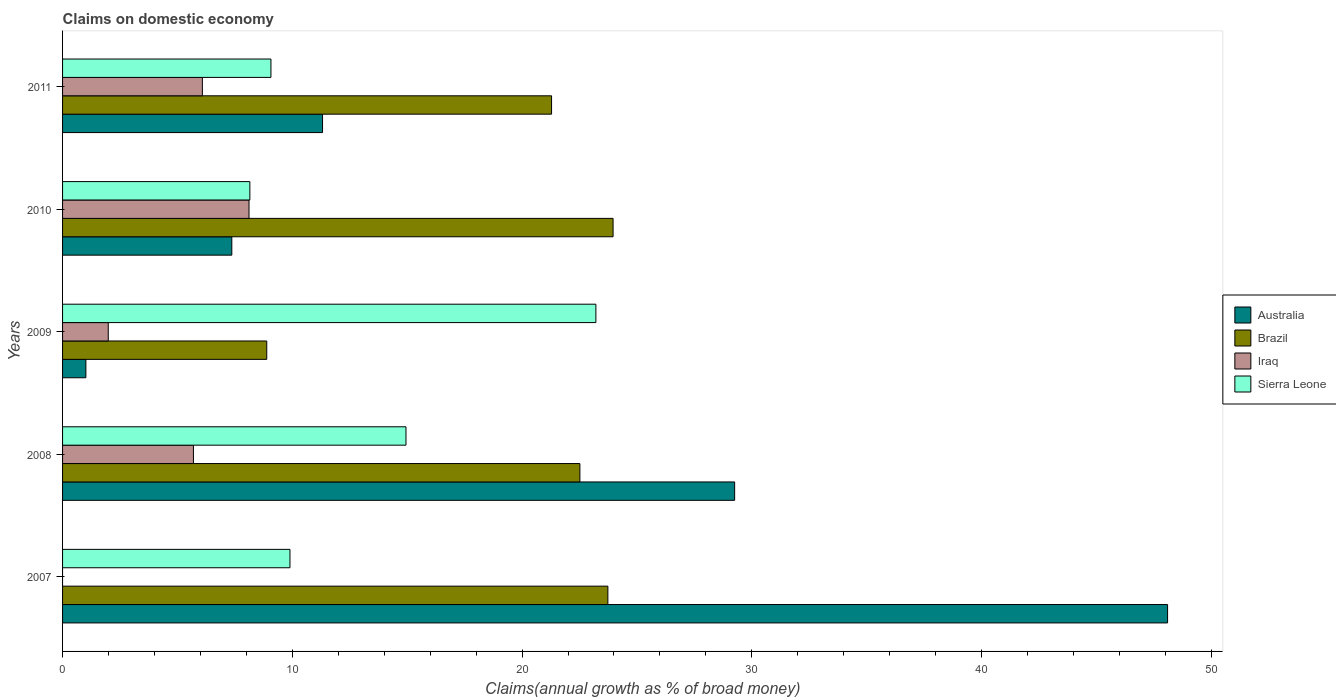How many groups of bars are there?
Provide a succinct answer. 5. Are the number of bars per tick equal to the number of legend labels?
Your response must be concise. No. How many bars are there on the 5th tick from the top?
Your answer should be compact. 3. How many bars are there on the 2nd tick from the bottom?
Keep it short and to the point. 4. What is the label of the 3rd group of bars from the top?
Your answer should be compact. 2009. What is the percentage of broad money claimed on domestic economy in Brazil in 2010?
Your answer should be compact. 23.96. Across all years, what is the maximum percentage of broad money claimed on domestic economy in Australia?
Your response must be concise. 48.1. Across all years, what is the minimum percentage of broad money claimed on domestic economy in Iraq?
Your answer should be very brief. 0. What is the total percentage of broad money claimed on domestic economy in Australia in the graph?
Your response must be concise. 97.05. What is the difference between the percentage of broad money claimed on domestic economy in Brazil in 2009 and that in 2010?
Provide a succinct answer. -15.07. What is the difference between the percentage of broad money claimed on domestic economy in Iraq in 2009 and the percentage of broad money claimed on domestic economy in Brazil in 2011?
Provide a short and direct response. -19.3. What is the average percentage of broad money claimed on domestic economy in Sierra Leone per year?
Your response must be concise. 13.06. In the year 2008, what is the difference between the percentage of broad money claimed on domestic economy in Brazil and percentage of broad money claimed on domestic economy in Australia?
Offer a terse response. -6.74. In how many years, is the percentage of broad money claimed on domestic economy in Iraq greater than 40 %?
Offer a very short reply. 0. What is the ratio of the percentage of broad money claimed on domestic economy in Iraq in 2010 to that in 2011?
Keep it short and to the point. 1.33. Is the percentage of broad money claimed on domestic economy in Brazil in 2007 less than that in 2011?
Your answer should be very brief. No. Is the difference between the percentage of broad money claimed on domestic economy in Brazil in 2007 and 2011 greater than the difference between the percentage of broad money claimed on domestic economy in Australia in 2007 and 2011?
Provide a short and direct response. No. What is the difference between the highest and the second highest percentage of broad money claimed on domestic economy in Australia?
Your answer should be very brief. 18.84. What is the difference between the highest and the lowest percentage of broad money claimed on domestic economy in Brazil?
Make the answer very short. 15.07. Is it the case that in every year, the sum of the percentage of broad money claimed on domestic economy in Sierra Leone and percentage of broad money claimed on domestic economy in Brazil is greater than the sum of percentage of broad money claimed on domestic economy in Australia and percentage of broad money claimed on domestic economy in Iraq?
Keep it short and to the point. No. Is it the case that in every year, the sum of the percentage of broad money claimed on domestic economy in Brazil and percentage of broad money claimed on domestic economy in Sierra Leone is greater than the percentage of broad money claimed on domestic economy in Australia?
Provide a short and direct response. No. How many years are there in the graph?
Provide a short and direct response. 5. What is the difference between two consecutive major ticks on the X-axis?
Provide a short and direct response. 10. Does the graph contain any zero values?
Your answer should be compact. Yes. Does the graph contain grids?
Provide a succinct answer. No. Where does the legend appear in the graph?
Offer a very short reply. Center right. How many legend labels are there?
Give a very brief answer. 4. How are the legend labels stacked?
Your response must be concise. Vertical. What is the title of the graph?
Make the answer very short. Claims on domestic economy. Does "United Arab Emirates" appear as one of the legend labels in the graph?
Keep it short and to the point. No. What is the label or title of the X-axis?
Keep it short and to the point. Claims(annual growth as % of broad money). What is the label or title of the Y-axis?
Provide a succinct answer. Years. What is the Claims(annual growth as % of broad money) of Australia in 2007?
Ensure brevity in your answer.  48.1. What is the Claims(annual growth as % of broad money) of Brazil in 2007?
Your answer should be compact. 23.73. What is the Claims(annual growth as % of broad money) in Iraq in 2007?
Provide a short and direct response. 0. What is the Claims(annual growth as % of broad money) in Sierra Leone in 2007?
Make the answer very short. 9.9. What is the Claims(annual growth as % of broad money) of Australia in 2008?
Provide a succinct answer. 29.25. What is the Claims(annual growth as % of broad money) in Brazil in 2008?
Offer a terse response. 22.52. What is the Claims(annual growth as % of broad money) of Iraq in 2008?
Offer a very short reply. 5.7. What is the Claims(annual growth as % of broad money) of Sierra Leone in 2008?
Give a very brief answer. 14.95. What is the Claims(annual growth as % of broad money) of Australia in 2009?
Your answer should be compact. 1.01. What is the Claims(annual growth as % of broad money) in Brazil in 2009?
Provide a succinct answer. 8.89. What is the Claims(annual growth as % of broad money) of Iraq in 2009?
Make the answer very short. 1.99. What is the Claims(annual growth as % of broad money) of Sierra Leone in 2009?
Provide a short and direct response. 23.21. What is the Claims(annual growth as % of broad money) of Australia in 2010?
Provide a short and direct response. 7.37. What is the Claims(annual growth as % of broad money) of Brazil in 2010?
Provide a short and direct response. 23.96. What is the Claims(annual growth as % of broad money) in Iraq in 2010?
Give a very brief answer. 8.12. What is the Claims(annual growth as % of broad money) of Sierra Leone in 2010?
Provide a succinct answer. 8.15. What is the Claims(annual growth as % of broad money) in Australia in 2011?
Provide a succinct answer. 11.32. What is the Claims(annual growth as % of broad money) in Brazil in 2011?
Offer a terse response. 21.28. What is the Claims(annual growth as % of broad money) in Iraq in 2011?
Offer a very short reply. 6.09. What is the Claims(annual growth as % of broad money) of Sierra Leone in 2011?
Provide a succinct answer. 9.07. Across all years, what is the maximum Claims(annual growth as % of broad money) of Australia?
Your answer should be very brief. 48.1. Across all years, what is the maximum Claims(annual growth as % of broad money) of Brazil?
Offer a terse response. 23.96. Across all years, what is the maximum Claims(annual growth as % of broad money) in Iraq?
Offer a terse response. 8.12. Across all years, what is the maximum Claims(annual growth as % of broad money) of Sierra Leone?
Provide a succinct answer. 23.21. Across all years, what is the minimum Claims(annual growth as % of broad money) of Australia?
Provide a succinct answer. 1.01. Across all years, what is the minimum Claims(annual growth as % of broad money) in Brazil?
Provide a short and direct response. 8.89. Across all years, what is the minimum Claims(annual growth as % of broad money) of Sierra Leone?
Keep it short and to the point. 8.15. What is the total Claims(annual growth as % of broad money) in Australia in the graph?
Provide a short and direct response. 97.05. What is the total Claims(annual growth as % of broad money) in Brazil in the graph?
Offer a very short reply. 100.38. What is the total Claims(annual growth as % of broad money) in Iraq in the graph?
Offer a terse response. 21.88. What is the total Claims(annual growth as % of broad money) of Sierra Leone in the graph?
Provide a succinct answer. 65.28. What is the difference between the Claims(annual growth as % of broad money) of Australia in 2007 and that in 2008?
Your response must be concise. 18.84. What is the difference between the Claims(annual growth as % of broad money) in Brazil in 2007 and that in 2008?
Ensure brevity in your answer.  1.22. What is the difference between the Claims(annual growth as % of broad money) in Sierra Leone in 2007 and that in 2008?
Your answer should be compact. -5.05. What is the difference between the Claims(annual growth as % of broad money) of Australia in 2007 and that in 2009?
Offer a very short reply. 47.08. What is the difference between the Claims(annual growth as % of broad money) of Brazil in 2007 and that in 2009?
Your answer should be very brief. 14.85. What is the difference between the Claims(annual growth as % of broad money) in Sierra Leone in 2007 and that in 2009?
Offer a terse response. -13.32. What is the difference between the Claims(annual growth as % of broad money) in Australia in 2007 and that in 2010?
Your answer should be very brief. 40.73. What is the difference between the Claims(annual growth as % of broad money) of Brazil in 2007 and that in 2010?
Offer a terse response. -0.23. What is the difference between the Claims(annual growth as % of broad money) in Sierra Leone in 2007 and that in 2010?
Your answer should be compact. 1.75. What is the difference between the Claims(annual growth as % of broad money) in Australia in 2007 and that in 2011?
Give a very brief answer. 36.78. What is the difference between the Claims(annual growth as % of broad money) of Brazil in 2007 and that in 2011?
Your answer should be compact. 2.45. What is the difference between the Claims(annual growth as % of broad money) of Sierra Leone in 2007 and that in 2011?
Offer a very short reply. 0.83. What is the difference between the Claims(annual growth as % of broad money) of Australia in 2008 and that in 2009?
Offer a very short reply. 28.24. What is the difference between the Claims(annual growth as % of broad money) of Brazil in 2008 and that in 2009?
Give a very brief answer. 13.63. What is the difference between the Claims(annual growth as % of broad money) of Iraq in 2008 and that in 2009?
Offer a terse response. 3.71. What is the difference between the Claims(annual growth as % of broad money) in Sierra Leone in 2008 and that in 2009?
Your response must be concise. -8.27. What is the difference between the Claims(annual growth as % of broad money) of Australia in 2008 and that in 2010?
Make the answer very short. 21.89. What is the difference between the Claims(annual growth as % of broad money) in Brazil in 2008 and that in 2010?
Provide a short and direct response. -1.45. What is the difference between the Claims(annual growth as % of broad money) in Iraq in 2008 and that in 2010?
Provide a short and direct response. -2.42. What is the difference between the Claims(annual growth as % of broad money) in Sierra Leone in 2008 and that in 2010?
Provide a succinct answer. 6.8. What is the difference between the Claims(annual growth as % of broad money) in Australia in 2008 and that in 2011?
Your response must be concise. 17.94. What is the difference between the Claims(annual growth as % of broad money) of Brazil in 2008 and that in 2011?
Provide a succinct answer. 1.23. What is the difference between the Claims(annual growth as % of broad money) in Iraq in 2008 and that in 2011?
Provide a short and direct response. -0.39. What is the difference between the Claims(annual growth as % of broad money) in Sierra Leone in 2008 and that in 2011?
Provide a short and direct response. 5.88. What is the difference between the Claims(annual growth as % of broad money) of Australia in 2009 and that in 2010?
Keep it short and to the point. -6.35. What is the difference between the Claims(annual growth as % of broad money) of Brazil in 2009 and that in 2010?
Keep it short and to the point. -15.07. What is the difference between the Claims(annual growth as % of broad money) of Iraq in 2009 and that in 2010?
Provide a succinct answer. -6.13. What is the difference between the Claims(annual growth as % of broad money) of Sierra Leone in 2009 and that in 2010?
Make the answer very short. 15.06. What is the difference between the Claims(annual growth as % of broad money) of Australia in 2009 and that in 2011?
Offer a terse response. -10.3. What is the difference between the Claims(annual growth as % of broad money) in Brazil in 2009 and that in 2011?
Offer a terse response. -12.4. What is the difference between the Claims(annual growth as % of broad money) in Iraq in 2009 and that in 2011?
Your answer should be very brief. -4.1. What is the difference between the Claims(annual growth as % of broad money) in Sierra Leone in 2009 and that in 2011?
Your response must be concise. 14.14. What is the difference between the Claims(annual growth as % of broad money) of Australia in 2010 and that in 2011?
Provide a short and direct response. -3.95. What is the difference between the Claims(annual growth as % of broad money) in Brazil in 2010 and that in 2011?
Keep it short and to the point. 2.68. What is the difference between the Claims(annual growth as % of broad money) of Iraq in 2010 and that in 2011?
Your answer should be compact. 2.03. What is the difference between the Claims(annual growth as % of broad money) of Sierra Leone in 2010 and that in 2011?
Provide a short and direct response. -0.92. What is the difference between the Claims(annual growth as % of broad money) of Australia in 2007 and the Claims(annual growth as % of broad money) of Brazil in 2008?
Offer a terse response. 25.58. What is the difference between the Claims(annual growth as % of broad money) of Australia in 2007 and the Claims(annual growth as % of broad money) of Iraq in 2008?
Offer a very short reply. 42.4. What is the difference between the Claims(annual growth as % of broad money) in Australia in 2007 and the Claims(annual growth as % of broad money) in Sierra Leone in 2008?
Make the answer very short. 33.15. What is the difference between the Claims(annual growth as % of broad money) in Brazil in 2007 and the Claims(annual growth as % of broad money) in Iraq in 2008?
Provide a succinct answer. 18.04. What is the difference between the Claims(annual growth as % of broad money) of Brazil in 2007 and the Claims(annual growth as % of broad money) of Sierra Leone in 2008?
Provide a short and direct response. 8.79. What is the difference between the Claims(annual growth as % of broad money) in Australia in 2007 and the Claims(annual growth as % of broad money) in Brazil in 2009?
Offer a terse response. 39.21. What is the difference between the Claims(annual growth as % of broad money) in Australia in 2007 and the Claims(annual growth as % of broad money) in Iraq in 2009?
Offer a terse response. 46.11. What is the difference between the Claims(annual growth as % of broad money) of Australia in 2007 and the Claims(annual growth as % of broad money) of Sierra Leone in 2009?
Your answer should be compact. 24.88. What is the difference between the Claims(annual growth as % of broad money) in Brazil in 2007 and the Claims(annual growth as % of broad money) in Iraq in 2009?
Your response must be concise. 21.75. What is the difference between the Claims(annual growth as % of broad money) of Brazil in 2007 and the Claims(annual growth as % of broad money) of Sierra Leone in 2009?
Give a very brief answer. 0.52. What is the difference between the Claims(annual growth as % of broad money) in Australia in 2007 and the Claims(annual growth as % of broad money) in Brazil in 2010?
Provide a short and direct response. 24.13. What is the difference between the Claims(annual growth as % of broad money) of Australia in 2007 and the Claims(annual growth as % of broad money) of Iraq in 2010?
Ensure brevity in your answer.  39.98. What is the difference between the Claims(annual growth as % of broad money) of Australia in 2007 and the Claims(annual growth as % of broad money) of Sierra Leone in 2010?
Your response must be concise. 39.94. What is the difference between the Claims(annual growth as % of broad money) of Brazil in 2007 and the Claims(annual growth as % of broad money) of Iraq in 2010?
Make the answer very short. 15.62. What is the difference between the Claims(annual growth as % of broad money) of Brazil in 2007 and the Claims(annual growth as % of broad money) of Sierra Leone in 2010?
Provide a succinct answer. 15.58. What is the difference between the Claims(annual growth as % of broad money) of Australia in 2007 and the Claims(annual growth as % of broad money) of Brazil in 2011?
Your answer should be compact. 26.81. What is the difference between the Claims(annual growth as % of broad money) of Australia in 2007 and the Claims(annual growth as % of broad money) of Iraq in 2011?
Keep it short and to the point. 42.01. What is the difference between the Claims(annual growth as % of broad money) of Australia in 2007 and the Claims(annual growth as % of broad money) of Sierra Leone in 2011?
Keep it short and to the point. 39.03. What is the difference between the Claims(annual growth as % of broad money) of Brazil in 2007 and the Claims(annual growth as % of broad money) of Iraq in 2011?
Provide a short and direct response. 17.65. What is the difference between the Claims(annual growth as % of broad money) of Brazil in 2007 and the Claims(annual growth as % of broad money) of Sierra Leone in 2011?
Give a very brief answer. 14.67. What is the difference between the Claims(annual growth as % of broad money) of Australia in 2008 and the Claims(annual growth as % of broad money) of Brazil in 2009?
Make the answer very short. 20.37. What is the difference between the Claims(annual growth as % of broad money) in Australia in 2008 and the Claims(annual growth as % of broad money) in Iraq in 2009?
Provide a succinct answer. 27.26. What is the difference between the Claims(annual growth as % of broad money) of Australia in 2008 and the Claims(annual growth as % of broad money) of Sierra Leone in 2009?
Provide a succinct answer. 6.04. What is the difference between the Claims(annual growth as % of broad money) of Brazil in 2008 and the Claims(annual growth as % of broad money) of Iraq in 2009?
Your answer should be compact. 20.53. What is the difference between the Claims(annual growth as % of broad money) of Brazil in 2008 and the Claims(annual growth as % of broad money) of Sierra Leone in 2009?
Provide a succinct answer. -0.7. What is the difference between the Claims(annual growth as % of broad money) of Iraq in 2008 and the Claims(annual growth as % of broad money) of Sierra Leone in 2009?
Your response must be concise. -17.52. What is the difference between the Claims(annual growth as % of broad money) of Australia in 2008 and the Claims(annual growth as % of broad money) of Brazil in 2010?
Offer a very short reply. 5.29. What is the difference between the Claims(annual growth as % of broad money) of Australia in 2008 and the Claims(annual growth as % of broad money) of Iraq in 2010?
Your answer should be compact. 21.14. What is the difference between the Claims(annual growth as % of broad money) of Australia in 2008 and the Claims(annual growth as % of broad money) of Sierra Leone in 2010?
Provide a short and direct response. 21.1. What is the difference between the Claims(annual growth as % of broad money) of Brazil in 2008 and the Claims(annual growth as % of broad money) of Iraq in 2010?
Provide a succinct answer. 14.4. What is the difference between the Claims(annual growth as % of broad money) in Brazil in 2008 and the Claims(annual growth as % of broad money) in Sierra Leone in 2010?
Your answer should be compact. 14.36. What is the difference between the Claims(annual growth as % of broad money) of Iraq in 2008 and the Claims(annual growth as % of broad money) of Sierra Leone in 2010?
Ensure brevity in your answer.  -2.46. What is the difference between the Claims(annual growth as % of broad money) in Australia in 2008 and the Claims(annual growth as % of broad money) in Brazil in 2011?
Make the answer very short. 7.97. What is the difference between the Claims(annual growth as % of broad money) of Australia in 2008 and the Claims(annual growth as % of broad money) of Iraq in 2011?
Offer a very short reply. 23.17. What is the difference between the Claims(annual growth as % of broad money) in Australia in 2008 and the Claims(annual growth as % of broad money) in Sierra Leone in 2011?
Provide a succinct answer. 20.18. What is the difference between the Claims(annual growth as % of broad money) in Brazil in 2008 and the Claims(annual growth as % of broad money) in Iraq in 2011?
Your answer should be compact. 16.43. What is the difference between the Claims(annual growth as % of broad money) in Brazil in 2008 and the Claims(annual growth as % of broad money) in Sierra Leone in 2011?
Offer a very short reply. 13.45. What is the difference between the Claims(annual growth as % of broad money) of Iraq in 2008 and the Claims(annual growth as % of broad money) of Sierra Leone in 2011?
Give a very brief answer. -3.37. What is the difference between the Claims(annual growth as % of broad money) in Australia in 2009 and the Claims(annual growth as % of broad money) in Brazil in 2010?
Ensure brevity in your answer.  -22.95. What is the difference between the Claims(annual growth as % of broad money) of Australia in 2009 and the Claims(annual growth as % of broad money) of Iraq in 2010?
Provide a short and direct response. -7.1. What is the difference between the Claims(annual growth as % of broad money) in Australia in 2009 and the Claims(annual growth as % of broad money) in Sierra Leone in 2010?
Provide a short and direct response. -7.14. What is the difference between the Claims(annual growth as % of broad money) of Brazil in 2009 and the Claims(annual growth as % of broad money) of Iraq in 2010?
Your answer should be compact. 0.77. What is the difference between the Claims(annual growth as % of broad money) of Brazil in 2009 and the Claims(annual growth as % of broad money) of Sierra Leone in 2010?
Offer a terse response. 0.74. What is the difference between the Claims(annual growth as % of broad money) of Iraq in 2009 and the Claims(annual growth as % of broad money) of Sierra Leone in 2010?
Your answer should be compact. -6.16. What is the difference between the Claims(annual growth as % of broad money) in Australia in 2009 and the Claims(annual growth as % of broad money) in Brazil in 2011?
Keep it short and to the point. -20.27. What is the difference between the Claims(annual growth as % of broad money) of Australia in 2009 and the Claims(annual growth as % of broad money) of Iraq in 2011?
Your answer should be very brief. -5.07. What is the difference between the Claims(annual growth as % of broad money) in Australia in 2009 and the Claims(annual growth as % of broad money) in Sierra Leone in 2011?
Keep it short and to the point. -8.05. What is the difference between the Claims(annual growth as % of broad money) in Brazil in 2009 and the Claims(annual growth as % of broad money) in Iraq in 2011?
Provide a short and direct response. 2.8. What is the difference between the Claims(annual growth as % of broad money) in Brazil in 2009 and the Claims(annual growth as % of broad money) in Sierra Leone in 2011?
Ensure brevity in your answer.  -0.18. What is the difference between the Claims(annual growth as % of broad money) in Iraq in 2009 and the Claims(annual growth as % of broad money) in Sierra Leone in 2011?
Keep it short and to the point. -7.08. What is the difference between the Claims(annual growth as % of broad money) of Australia in 2010 and the Claims(annual growth as % of broad money) of Brazil in 2011?
Make the answer very short. -13.92. What is the difference between the Claims(annual growth as % of broad money) in Australia in 2010 and the Claims(annual growth as % of broad money) in Iraq in 2011?
Make the answer very short. 1.28. What is the difference between the Claims(annual growth as % of broad money) in Australia in 2010 and the Claims(annual growth as % of broad money) in Sierra Leone in 2011?
Your response must be concise. -1.7. What is the difference between the Claims(annual growth as % of broad money) in Brazil in 2010 and the Claims(annual growth as % of broad money) in Iraq in 2011?
Provide a succinct answer. 17.88. What is the difference between the Claims(annual growth as % of broad money) of Brazil in 2010 and the Claims(annual growth as % of broad money) of Sierra Leone in 2011?
Your response must be concise. 14.89. What is the difference between the Claims(annual growth as % of broad money) of Iraq in 2010 and the Claims(annual growth as % of broad money) of Sierra Leone in 2011?
Your answer should be compact. -0.95. What is the average Claims(annual growth as % of broad money) of Australia per year?
Give a very brief answer. 19.41. What is the average Claims(annual growth as % of broad money) in Brazil per year?
Provide a short and direct response. 20.08. What is the average Claims(annual growth as % of broad money) of Iraq per year?
Make the answer very short. 4.38. What is the average Claims(annual growth as % of broad money) of Sierra Leone per year?
Offer a terse response. 13.06. In the year 2007, what is the difference between the Claims(annual growth as % of broad money) of Australia and Claims(annual growth as % of broad money) of Brazil?
Provide a succinct answer. 24.36. In the year 2007, what is the difference between the Claims(annual growth as % of broad money) in Australia and Claims(annual growth as % of broad money) in Sierra Leone?
Your response must be concise. 38.2. In the year 2007, what is the difference between the Claims(annual growth as % of broad money) in Brazil and Claims(annual growth as % of broad money) in Sierra Leone?
Offer a very short reply. 13.84. In the year 2008, what is the difference between the Claims(annual growth as % of broad money) in Australia and Claims(annual growth as % of broad money) in Brazil?
Provide a short and direct response. 6.74. In the year 2008, what is the difference between the Claims(annual growth as % of broad money) in Australia and Claims(annual growth as % of broad money) in Iraq?
Offer a terse response. 23.56. In the year 2008, what is the difference between the Claims(annual growth as % of broad money) in Australia and Claims(annual growth as % of broad money) in Sierra Leone?
Your answer should be compact. 14.31. In the year 2008, what is the difference between the Claims(annual growth as % of broad money) of Brazil and Claims(annual growth as % of broad money) of Iraq?
Make the answer very short. 16.82. In the year 2008, what is the difference between the Claims(annual growth as % of broad money) in Brazil and Claims(annual growth as % of broad money) in Sierra Leone?
Your response must be concise. 7.57. In the year 2008, what is the difference between the Claims(annual growth as % of broad money) of Iraq and Claims(annual growth as % of broad money) of Sierra Leone?
Provide a succinct answer. -9.25. In the year 2009, what is the difference between the Claims(annual growth as % of broad money) of Australia and Claims(annual growth as % of broad money) of Brazil?
Keep it short and to the point. -7.87. In the year 2009, what is the difference between the Claims(annual growth as % of broad money) in Australia and Claims(annual growth as % of broad money) in Iraq?
Provide a succinct answer. -0.97. In the year 2009, what is the difference between the Claims(annual growth as % of broad money) in Australia and Claims(annual growth as % of broad money) in Sierra Leone?
Your response must be concise. -22.2. In the year 2009, what is the difference between the Claims(annual growth as % of broad money) in Brazil and Claims(annual growth as % of broad money) in Iraq?
Provide a short and direct response. 6.9. In the year 2009, what is the difference between the Claims(annual growth as % of broad money) in Brazil and Claims(annual growth as % of broad money) in Sierra Leone?
Your response must be concise. -14.33. In the year 2009, what is the difference between the Claims(annual growth as % of broad money) of Iraq and Claims(annual growth as % of broad money) of Sierra Leone?
Your answer should be very brief. -21.23. In the year 2010, what is the difference between the Claims(annual growth as % of broad money) of Australia and Claims(annual growth as % of broad money) of Brazil?
Keep it short and to the point. -16.59. In the year 2010, what is the difference between the Claims(annual growth as % of broad money) in Australia and Claims(annual growth as % of broad money) in Iraq?
Give a very brief answer. -0.75. In the year 2010, what is the difference between the Claims(annual growth as % of broad money) in Australia and Claims(annual growth as % of broad money) in Sierra Leone?
Your answer should be compact. -0.79. In the year 2010, what is the difference between the Claims(annual growth as % of broad money) of Brazil and Claims(annual growth as % of broad money) of Iraq?
Offer a very short reply. 15.85. In the year 2010, what is the difference between the Claims(annual growth as % of broad money) in Brazil and Claims(annual growth as % of broad money) in Sierra Leone?
Make the answer very short. 15.81. In the year 2010, what is the difference between the Claims(annual growth as % of broad money) of Iraq and Claims(annual growth as % of broad money) of Sierra Leone?
Give a very brief answer. -0.04. In the year 2011, what is the difference between the Claims(annual growth as % of broad money) of Australia and Claims(annual growth as % of broad money) of Brazil?
Ensure brevity in your answer.  -9.97. In the year 2011, what is the difference between the Claims(annual growth as % of broad money) in Australia and Claims(annual growth as % of broad money) in Iraq?
Your answer should be compact. 5.23. In the year 2011, what is the difference between the Claims(annual growth as % of broad money) of Australia and Claims(annual growth as % of broad money) of Sierra Leone?
Ensure brevity in your answer.  2.25. In the year 2011, what is the difference between the Claims(annual growth as % of broad money) in Brazil and Claims(annual growth as % of broad money) in Iraq?
Your response must be concise. 15.2. In the year 2011, what is the difference between the Claims(annual growth as % of broad money) of Brazil and Claims(annual growth as % of broad money) of Sierra Leone?
Provide a short and direct response. 12.21. In the year 2011, what is the difference between the Claims(annual growth as % of broad money) in Iraq and Claims(annual growth as % of broad money) in Sierra Leone?
Your answer should be compact. -2.98. What is the ratio of the Claims(annual growth as % of broad money) of Australia in 2007 to that in 2008?
Make the answer very short. 1.64. What is the ratio of the Claims(annual growth as % of broad money) of Brazil in 2007 to that in 2008?
Your answer should be very brief. 1.05. What is the ratio of the Claims(annual growth as % of broad money) in Sierra Leone in 2007 to that in 2008?
Your answer should be very brief. 0.66. What is the ratio of the Claims(annual growth as % of broad money) in Australia in 2007 to that in 2009?
Provide a succinct answer. 47.4. What is the ratio of the Claims(annual growth as % of broad money) of Brazil in 2007 to that in 2009?
Provide a succinct answer. 2.67. What is the ratio of the Claims(annual growth as % of broad money) of Sierra Leone in 2007 to that in 2009?
Your answer should be compact. 0.43. What is the ratio of the Claims(annual growth as % of broad money) of Australia in 2007 to that in 2010?
Your answer should be compact. 6.53. What is the ratio of the Claims(annual growth as % of broad money) in Brazil in 2007 to that in 2010?
Provide a succinct answer. 0.99. What is the ratio of the Claims(annual growth as % of broad money) in Sierra Leone in 2007 to that in 2010?
Your answer should be very brief. 1.21. What is the ratio of the Claims(annual growth as % of broad money) of Australia in 2007 to that in 2011?
Provide a succinct answer. 4.25. What is the ratio of the Claims(annual growth as % of broad money) in Brazil in 2007 to that in 2011?
Your answer should be very brief. 1.12. What is the ratio of the Claims(annual growth as % of broad money) in Sierra Leone in 2007 to that in 2011?
Your answer should be compact. 1.09. What is the ratio of the Claims(annual growth as % of broad money) of Australia in 2008 to that in 2009?
Offer a very short reply. 28.83. What is the ratio of the Claims(annual growth as % of broad money) in Brazil in 2008 to that in 2009?
Offer a very short reply. 2.53. What is the ratio of the Claims(annual growth as % of broad money) in Iraq in 2008 to that in 2009?
Offer a terse response. 2.86. What is the ratio of the Claims(annual growth as % of broad money) in Sierra Leone in 2008 to that in 2009?
Provide a short and direct response. 0.64. What is the ratio of the Claims(annual growth as % of broad money) of Australia in 2008 to that in 2010?
Ensure brevity in your answer.  3.97. What is the ratio of the Claims(annual growth as % of broad money) of Brazil in 2008 to that in 2010?
Offer a very short reply. 0.94. What is the ratio of the Claims(annual growth as % of broad money) of Iraq in 2008 to that in 2010?
Provide a succinct answer. 0.7. What is the ratio of the Claims(annual growth as % of broad money) of Sierra Leone in 2008 to that in 2010?
Offer a very short reply. 1.83. What is the ratio of the Claims(annual growth as % of broad money) in Australia in 2008 to that in 2011?
Your response must be concise. 2.59. What is the ratio of the Claims(annual growth as % of broad money) in Brazil in 2008 to that in 2011?
Keep it short and to the point. 1.06. What is the ratio of the Claims(annual growth as % of broad money) of Iraq in 2008 to that in 2011?
Offer a very short reply. 0.94. What is the ratio of the Claims(annual growth as % of broad money) in Sierra Leone in 2008 to that in 2011?
Provide a succinct answer. 1.65. What is the ratio of the Claims(annual growth as % of broad money) in Australia in 2009 to that in 2010?
Make the answer very short. 0.14. What is the ratio of the Claims(annual growth as % of broad money) in Brazil in 2009 to that in 2010?
Make the answer very short. 0.37. What is the ratio of the Claims(annual growth as % of broad money) of Iraq in 2009 to that in 2010?
Give a very brief answer. 0.24. What is the ratio of the Claims(annual growth as % of broad money) in Sierra Leone in 2009 to that in 2010?
Offer a terse response. 2.85. What is the ratio of the Claims(annual growth as % of broad money) of Australia in 2009 to that in 2011?
Provide a short and direct response. 0.09. What is the ratio of the Claims(annual growth as % of broad money) of Brazil in 2009 to that in 2011?
Your answer should be very brief. 0.42. What is the ratio of the Claims(annual growth as % of broad money) in Iraq in 2009 to that in 2011?
Offer a very short reply. 0.33. What is the ratio of the Claims(annual growth as % of broad money) in Sierra Leone in 2009 to that in 2011?
Provide a short and direct response. 2.56. What is the ratio of the Claims(annual growth as % of broad money) of Australia in 2010 to that in 2011?
Keep it short and to the point. 0.65. What is the ratio of the Claims(annual growth as % of broad money) of Brazil in 2010 to that in 2011?
Your response must be concise. 1.13. What is the ratio of the Claims(annual growth as % of broad money) in Iraq in 2010 to that in 2011?
Ensure brevity in your answer.  1.33. What is the ratio of the Claims(annual growth as % of broad money) in Sierra Leone in 2010 to that in 2011?
Your answer should be very brief. 0.9. What is the difference between the highest and the second highest Claims(annual growth as % of broad money) of Australia?
Your answer should be compact. 18.84. What is the difference between the highest and the second highest Claims(annual growth as % of broad money) of Brazil?
Make the answer very short. 0.23. What is the difference between the highest and the second highest Claims(annual growth as % of broad money) of Iraq?
Your answer should be compact. 2.03. What is the difference between the highest and the second highest Claims(annual growth as % of broad money) in Sierra Leone?
Offer a very short reply. 8.27. What is the difference between the highest and the lowest Claims(annual growth as % of broad money) in Australia?
Give a very brief answer. 47.08. What is the difference between the highest and the lowest Claims(annual growth as % of broad money) in Brazil?
Your answer should be compact. 15.07. What is the difference between the highest and the lowest Claims(annual growth as % of broad money) of Iraq?
Offer a very short reply. 8.12. What is the difference between the highest and the lowest Claims(annual growth as % of broad money) in Sierra Leone?
Your answer should be compact. 15.06. 